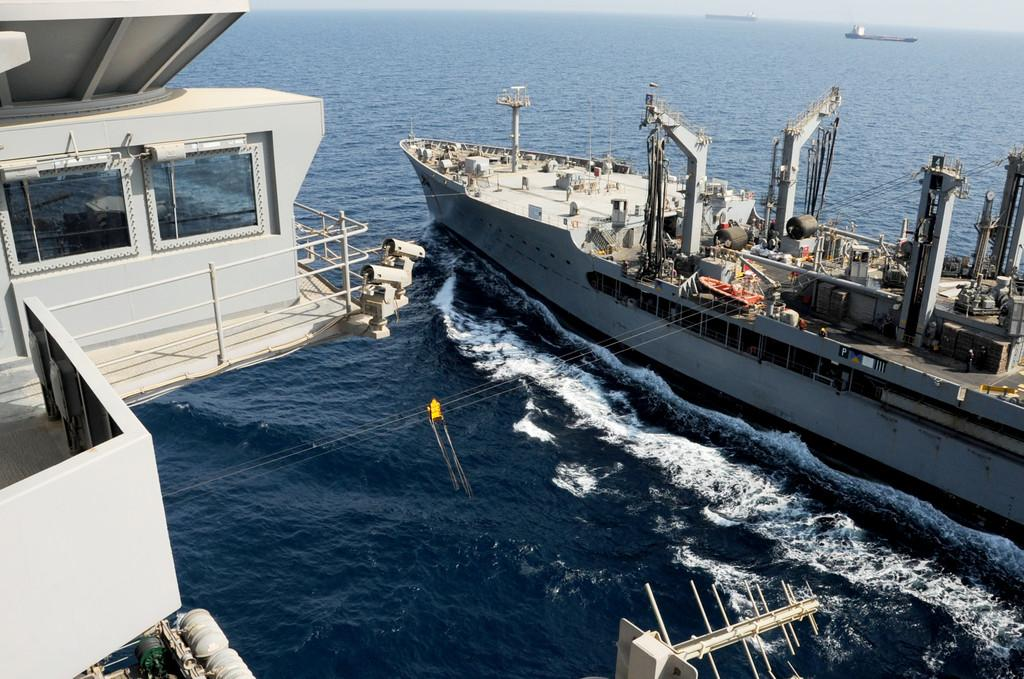What is floating on the water in the image? There is a ship floating on the water in the image. What can be seen in the background of the image? There is an ocean in the background of the image. How many ships are visible in the image? There are two ships visible in the image. What type of rice is being served on the cake in the image? There is no rice or cake present in the image; it features two ships floating on the water. Are there any giants visible in the image? There are no giants present in the image; it features two ships floating on the water. 